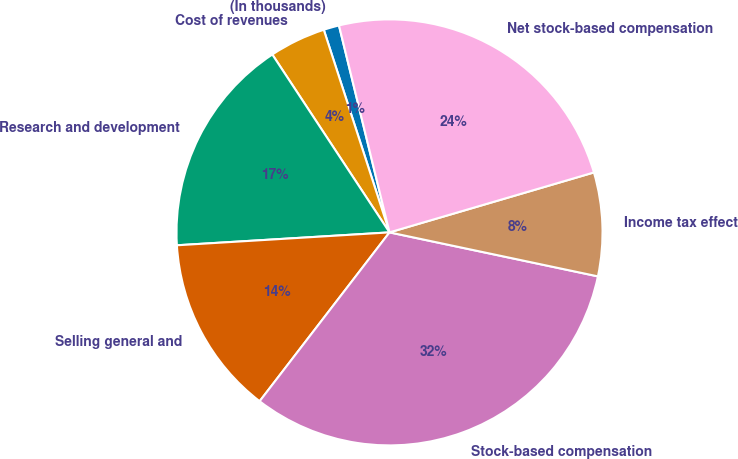Convert chart to OTSL. <chart><loc_0><loc_0><loc_500><loc_500><pie_chart><fcel>(In thousands)<fcel>Cost of revenues<fcel>Research and development<fcel>Selling general and<fcel>Stock-based compensation<fcel>Income tax effect<fcel>Net stock-based compensation<nl><fcel>1.18%<fcel>4.28%<fcel>16.69%<fcel>13.6%<fcel>32.12%<fcel>7.85%<fcel>24.27%<nl></chart> 